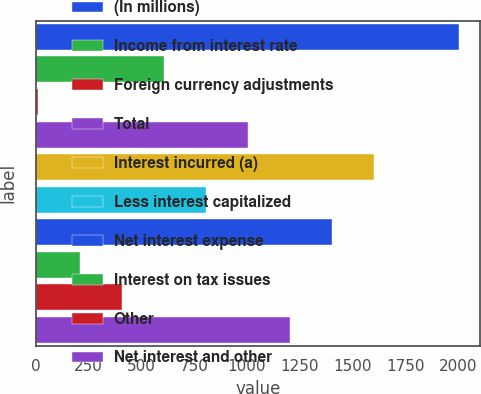Convert chart to OTSL. <chart><loc_0><loc_0><loc_500><loc_500><bar_chart><fcel>(In millions)<fcel>Income from interest rate<fcel>Foreign currency adjustments<fcel>Total<fcel>Interest incurred (a)<fcel>Less interest capitalized<fcel>Net interest expense<fcel>Interest on tax issues<fcel>Other<fcel>Net interest and other<nl><fcel>2004<fcel>607.5<fcel>9<fcel>1006.5<fcel>1605<fcel>807<fcel>1405.5<fcel>208.5<fcel>408<fcel>1206<nl></chart> 